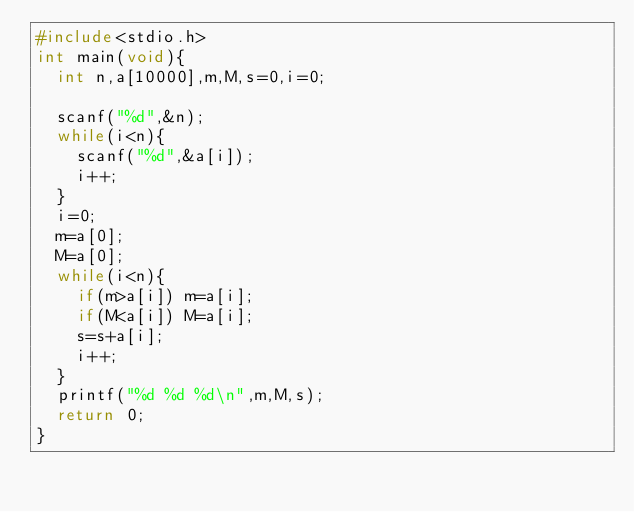Convert code to text. <code><loc_0><loc_0><loc_500><loc_500><_C_>#include<stdio.h>
int main(void){
	int n,a[10000],m,M,s=0,i=0;
	
	scanf("%d",&n);
	while(i<n){
		scanf("%d",&a[i]);
		i++;
	}
	i=0;	
	m=a[0];
	M=a[0];
	while(i<n){
		if(m>a[i]) m=a[i];
		if(M<a[i]) M=a[i];
		s=s+a[i];
		i++;
	}
	printf("%d %d %d\n",m,M,s);
	return 0;
}</code> 